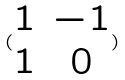<formula> <loc_0><loc_0><loc_500><loc_500>( \begin{matrix} 1 & - 1 \\ 1 & 0 \end{matrix} )</formula> 